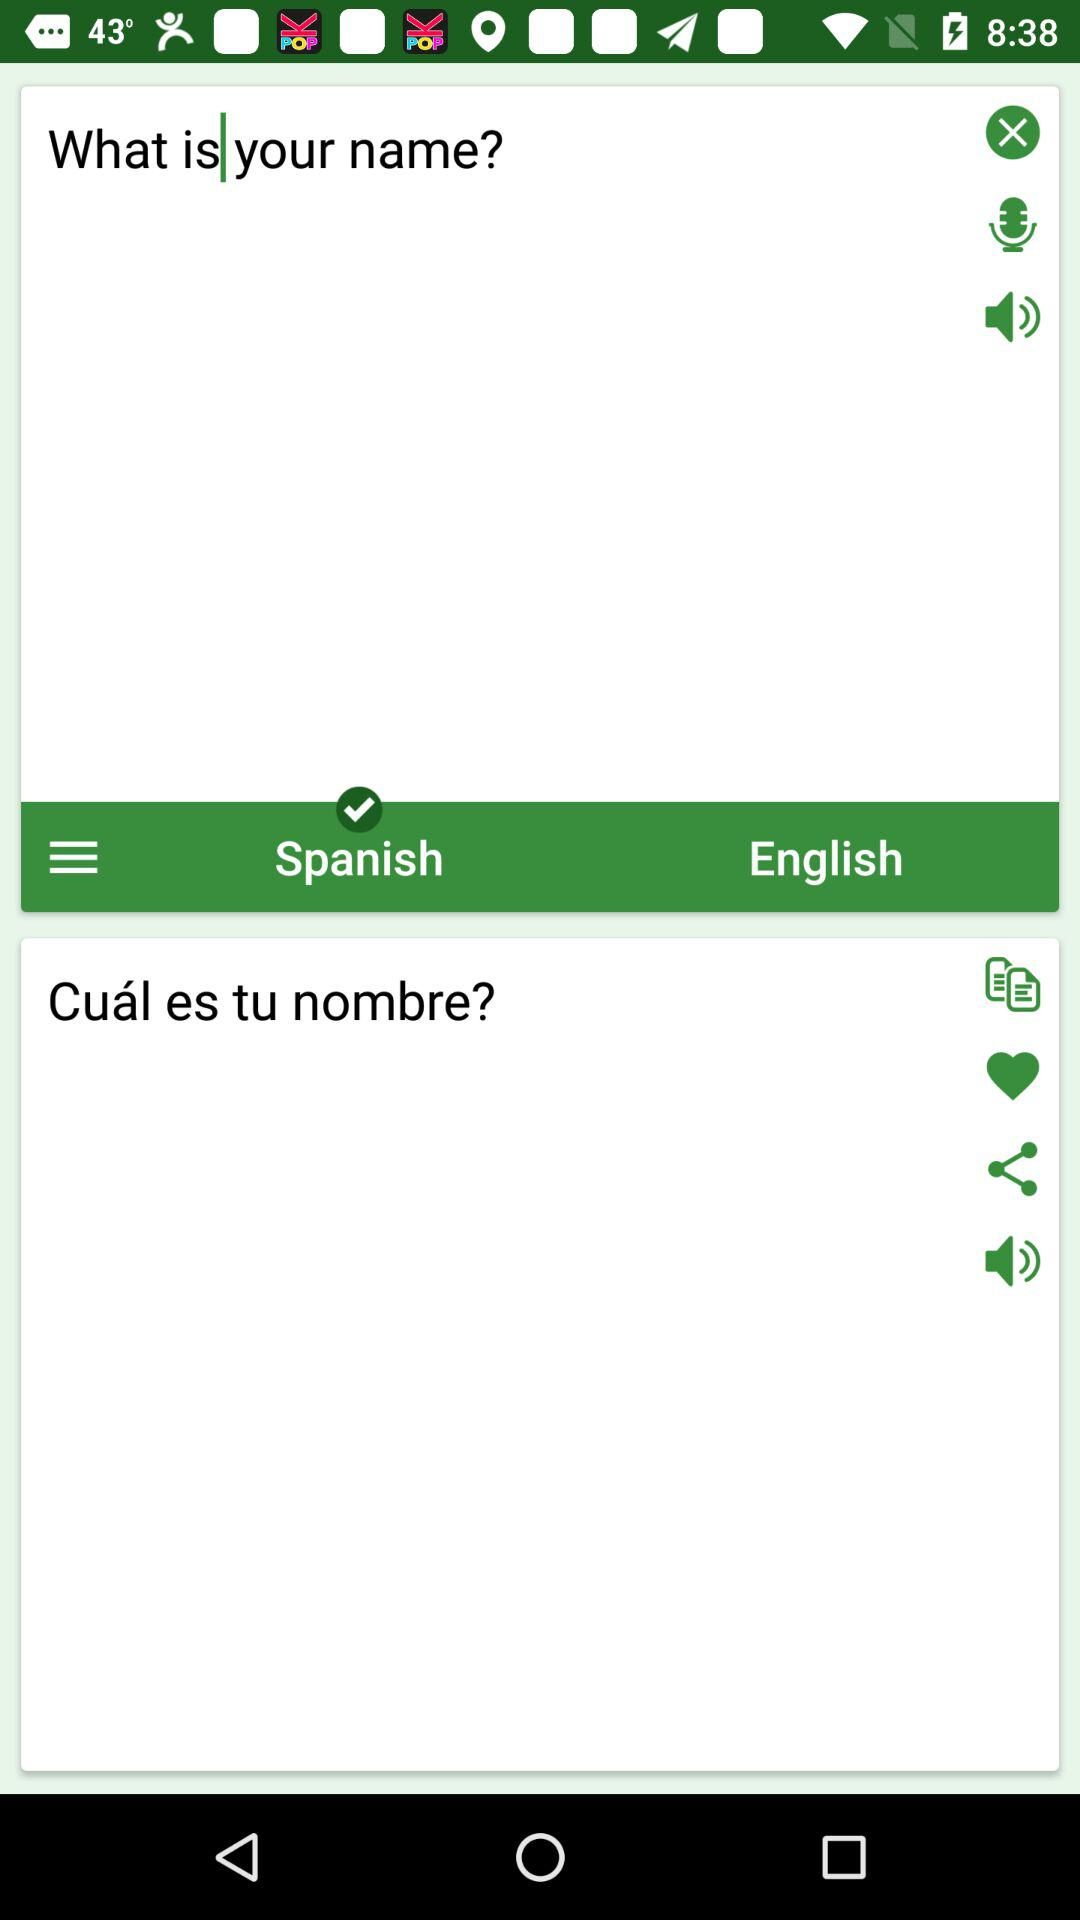Which level is the volume on?
When the provided information is insufficient, respond with <no answer>. <no answer> 